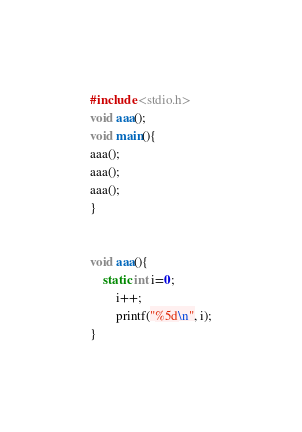<code> <loc_0><loc_0><loc_500><loc_500><_C_>#include <stdio.h>
void aaa();
void main(){
aaa();
aaa();
aaa();
}


void aaa(){
    static int i=0;
        i++;
        printf("%5d\n", i);
}</code> 